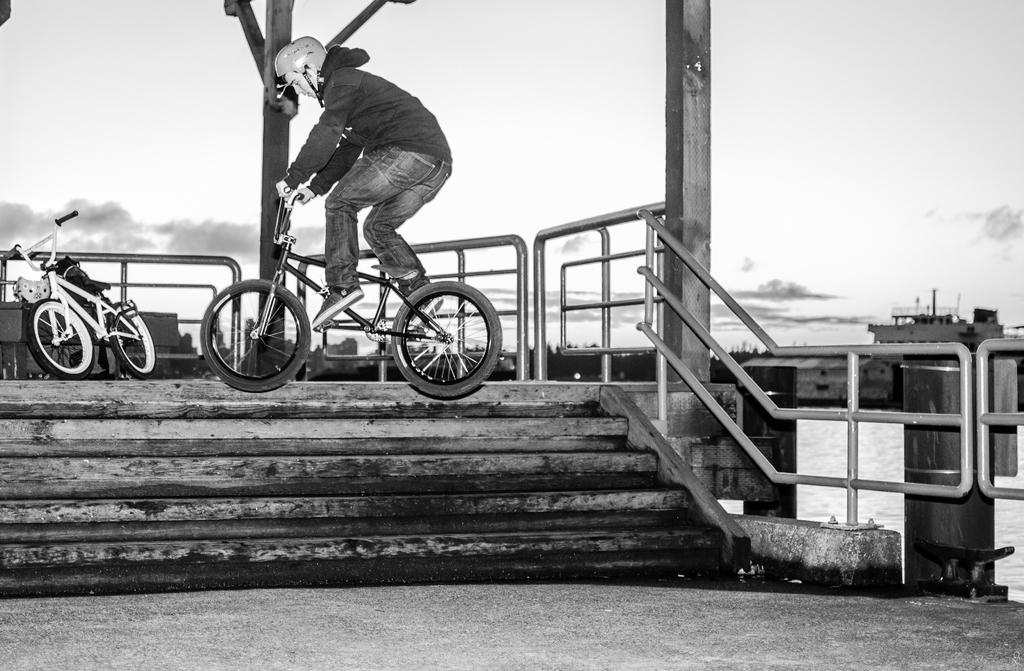Describe this image in one or two sentences. This is a black and white image. A person is riding a bicycle. there are stairs and fencing, other bicycle is present behind him. 